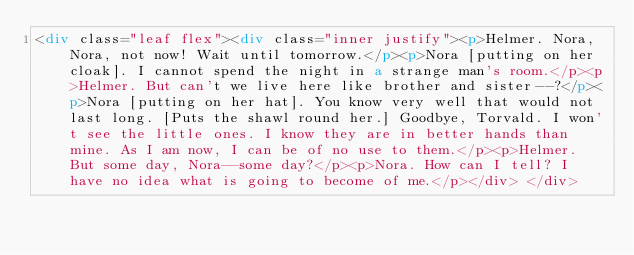Convert code to text. <code><loc_0><loc_0><loc_500><loc_500><_HTML_><div class="leaf flex"><div class="inner justify"><p>Helmer. Nora, Nora, not now! Wait until tomorrow.</p><p>Nora [putting on her cloak]. I cannot spend the night in a strange man's room.</p><p>Helmer. But can't we live here like brother and sister--?</p><p>Nora [putting on her hat]. You know very well that would not last long. [Puts the shawl round her.] Goodbye, Torvald. I won't see the little ones. I know they are in better hands than mine. As I am now, I can be of no use to them.</p><p>Helmer. But some day, Nora--some day?</p><p>Nora. How can I tell? I have no idea what is going to become of me.</p></div> </div></code> 